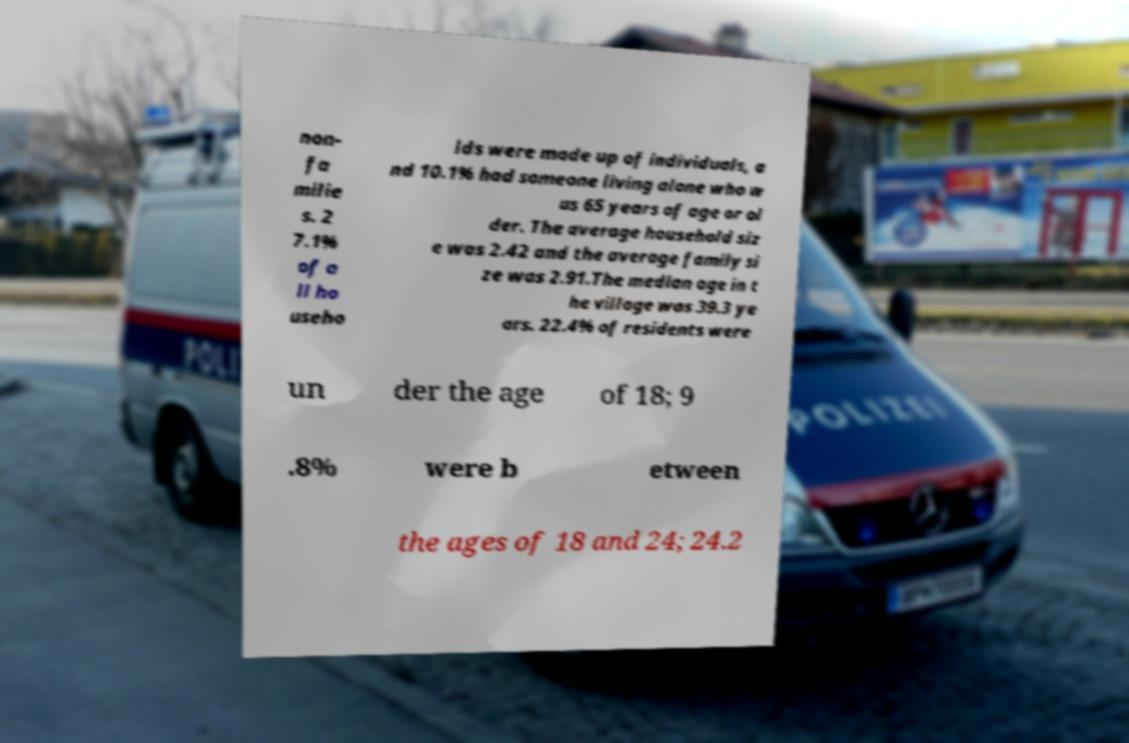Can you read and provide the text displayed in the image?This photo seems to have some interesting text. Can you extract and type it out for me? non- fa milie s. 2 7.1% of a ll ho useho lds were made up of individuals, a nd 10.1% had someone living alone who w as 65 years of age or ol der. The average household siz e was 2.42 and the average family si ze was 2.91.The median age in t he village was 39.3 ye ars. 22.4% of residents were un der the age of 18; 9 .8% were b etween the ages of 18 and 24; 24.2 